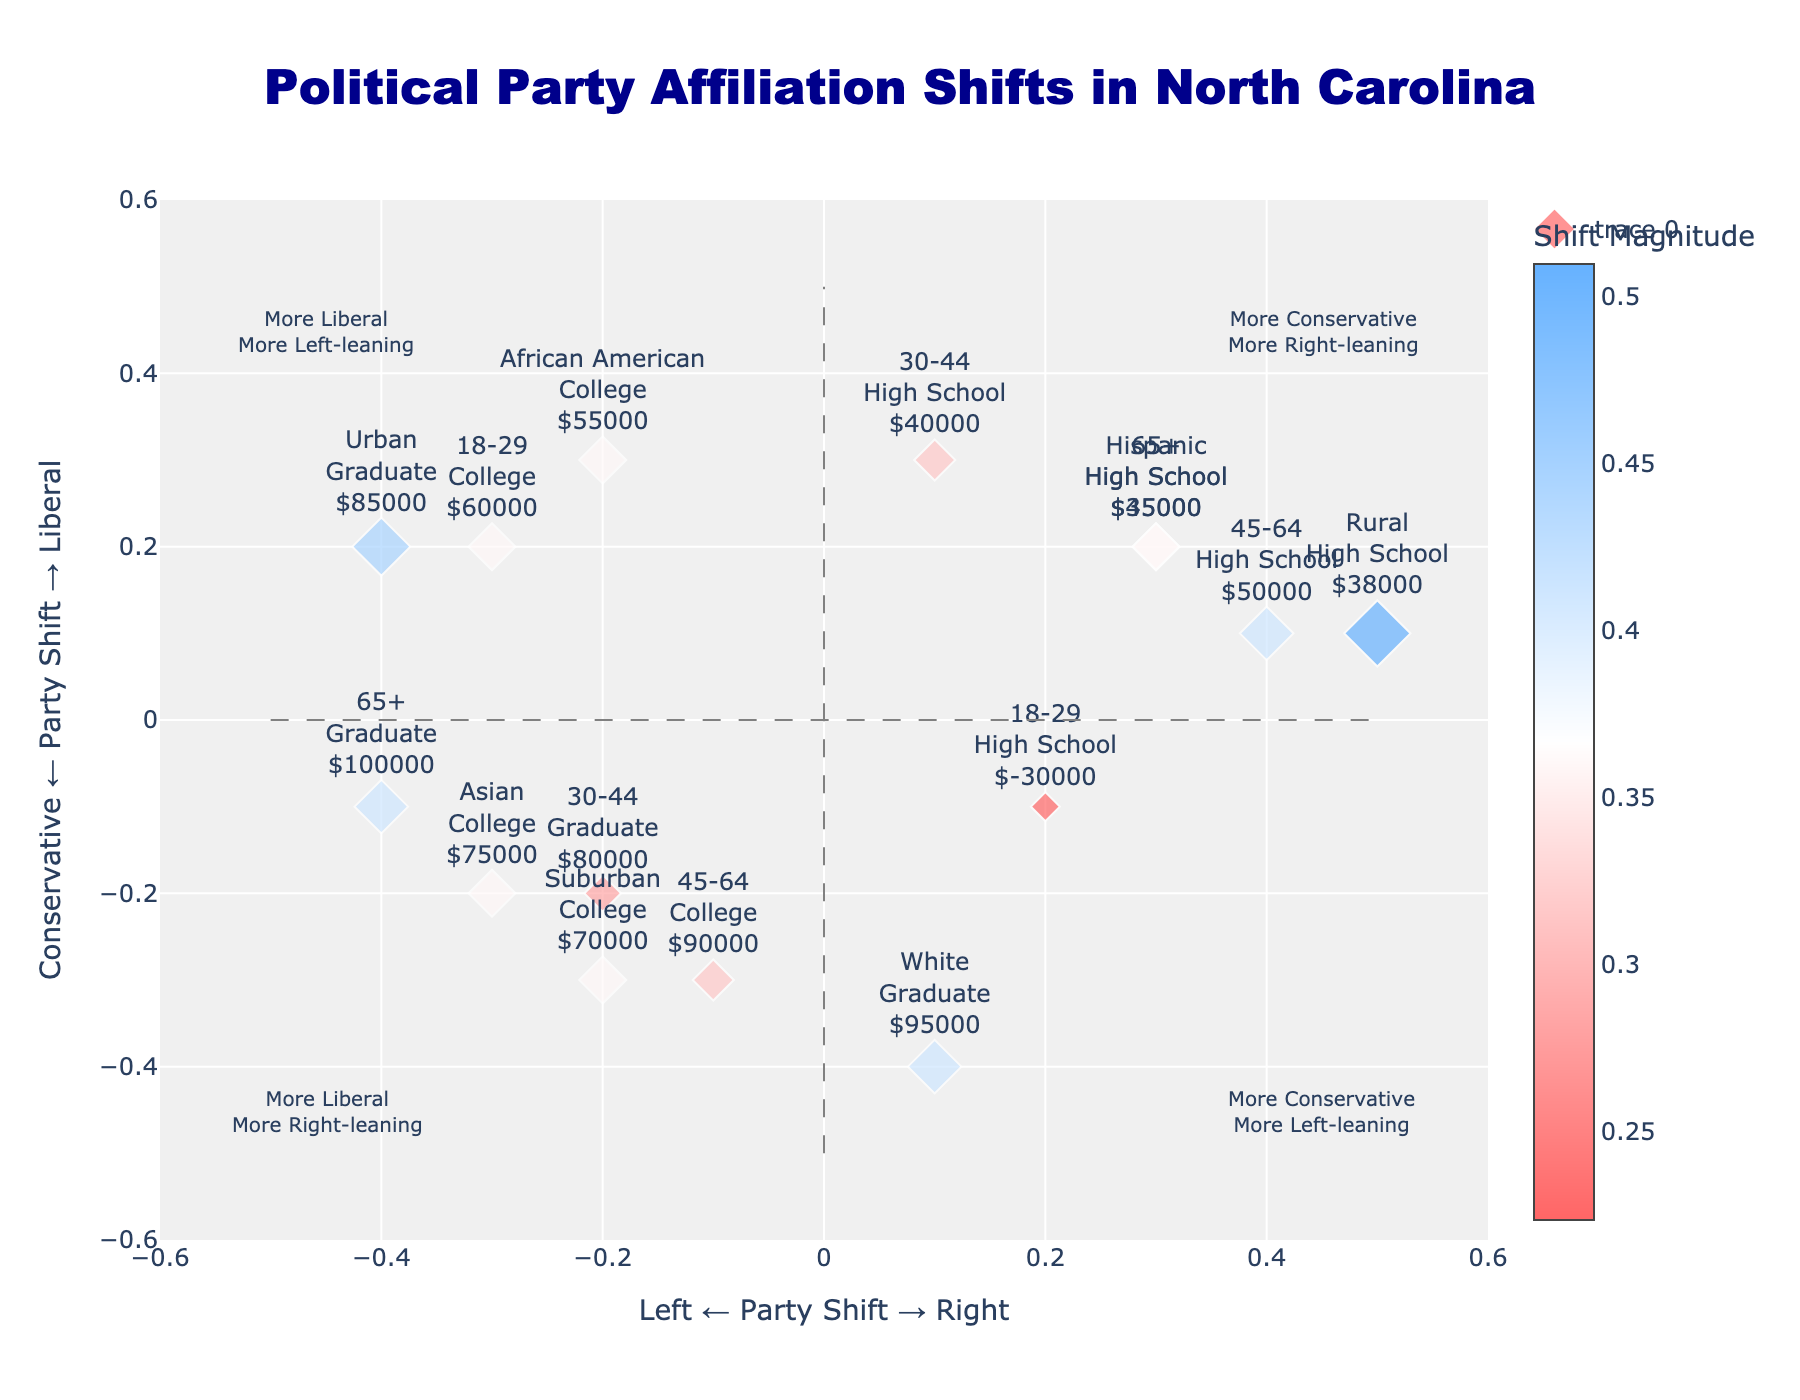What does the color of an arrow represent in the plot? The color represents the magnitude of the shift in political party affiliation, with a custom colorscale indicating the intensity. The color ranges from red (smaller shifts) to blue (larger shifts).
Answer: Magnitude of the shift How many demographic groups showed a shift towards more liberal and left-leaning affiliation? To find this, look at the arrows located in the upper-left quadrant of the plot. There are 5 arrows in this quadrant for shifts towards more liberal and left-leaning affiliation.
Answer: 5 Which demographic group has the largest leftward and conservative shift? This can be determined by finding the arrow with the largest negative value in the X-axis and a relatively high positive value in the Y-axis. The "Suburban, College" group has a Party_Shift_X of -0.2 and Party_Shift_Y of -0.3, indicating a large shift to the left and towards conservatism.
Answer: Suburban, College What is the direction and magnitude of shift for the "18-29, College" demographic group? The arrow for this group should be inspected. It has a direction towards the left and more liberal (Party_Shift_X of -0.3 and Party_Shift_Y of 0.2), with a magnitude calculated as sqrt(0.3^2 + 0.2^2) ≈ 0.36.
Answer: Left and liberal, magnitude ≈ 0.36 Which demographic group shows a shift towards more right-leaning and conservative values? To determine this, look for arrows in the lower-right quadrant of the plot. The "45-64, High School" group has a Party_Shift_X of 0.4 and Party_Shift_Y of 0.1, showing a shift towards more right-leaning and conservative values.
Answer: 45-64, High School Among the demographic groups who have a college education, which one shows the largest shift in terms of magnitude? First, identify all college-educated demographics. Then compare their shift magnitudes by looking at the lengths of their arrows. The "Asian, College" group has the largest magnitude when calculating sqrt(0.3^2 + 0.2^2) ≈ 0.36.
Answer: Asian, College What is the overall trend for the "Hispanic, High School" demographic? Inspect the arrow for this group. It shows a Party_Shift_X of 0.3 and Party_Shift_Y of 0.2, indicating a rightward, more liberal shift.
Answer: Rightward, more liberal How does the shift direction of the "Rural, High School" group compare to "Urban, Graduate"? Compare both arrows: "Rural, High School" shifts to the right and more conservative (Party_Shift_X of 0.5, Party_Shift_Y of 0.1) while "Urban, Graduate" shifts left and more liberal (Party_Shift_X of -0.4, Party_Shift_Y of 0.2).
Answer: Opposite directions—Rural shifts right and more conservative, Urban shifts left and more liberal 